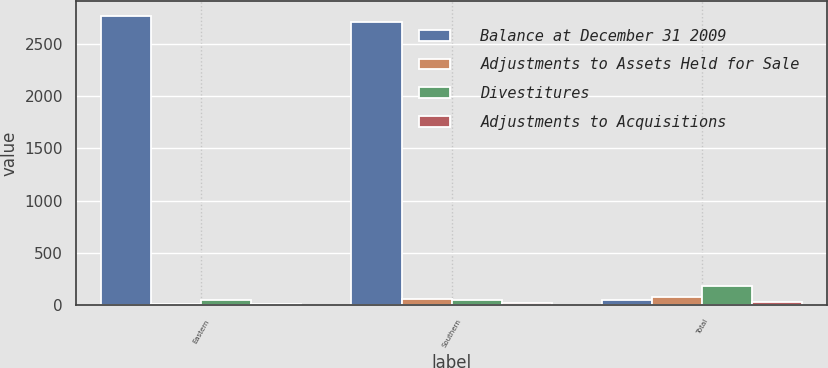Convert chart to OTSL. <chart><loc_0><loc_0><loc_500><loc_500><stacked_bar_chart><ecel><fcel>Eastern<fcel>Southern<fcel>Total<nl><fcel>Balance at December 31 2009<fcel>2772.5<fcel>2715.6<fcel>48.6<nl><fcel>Adjustments to Assets Held for Sale<fcel>11.2<fcel>61.8<fcel>73<nl><fcel>Divestitures<fcel>45<fcel>48.6<fcel>184.4<nl><fcel>Adjustments to Acquisitions<fcel>12.2<fcel>22.3<fcel>34.2<nl></chart> 